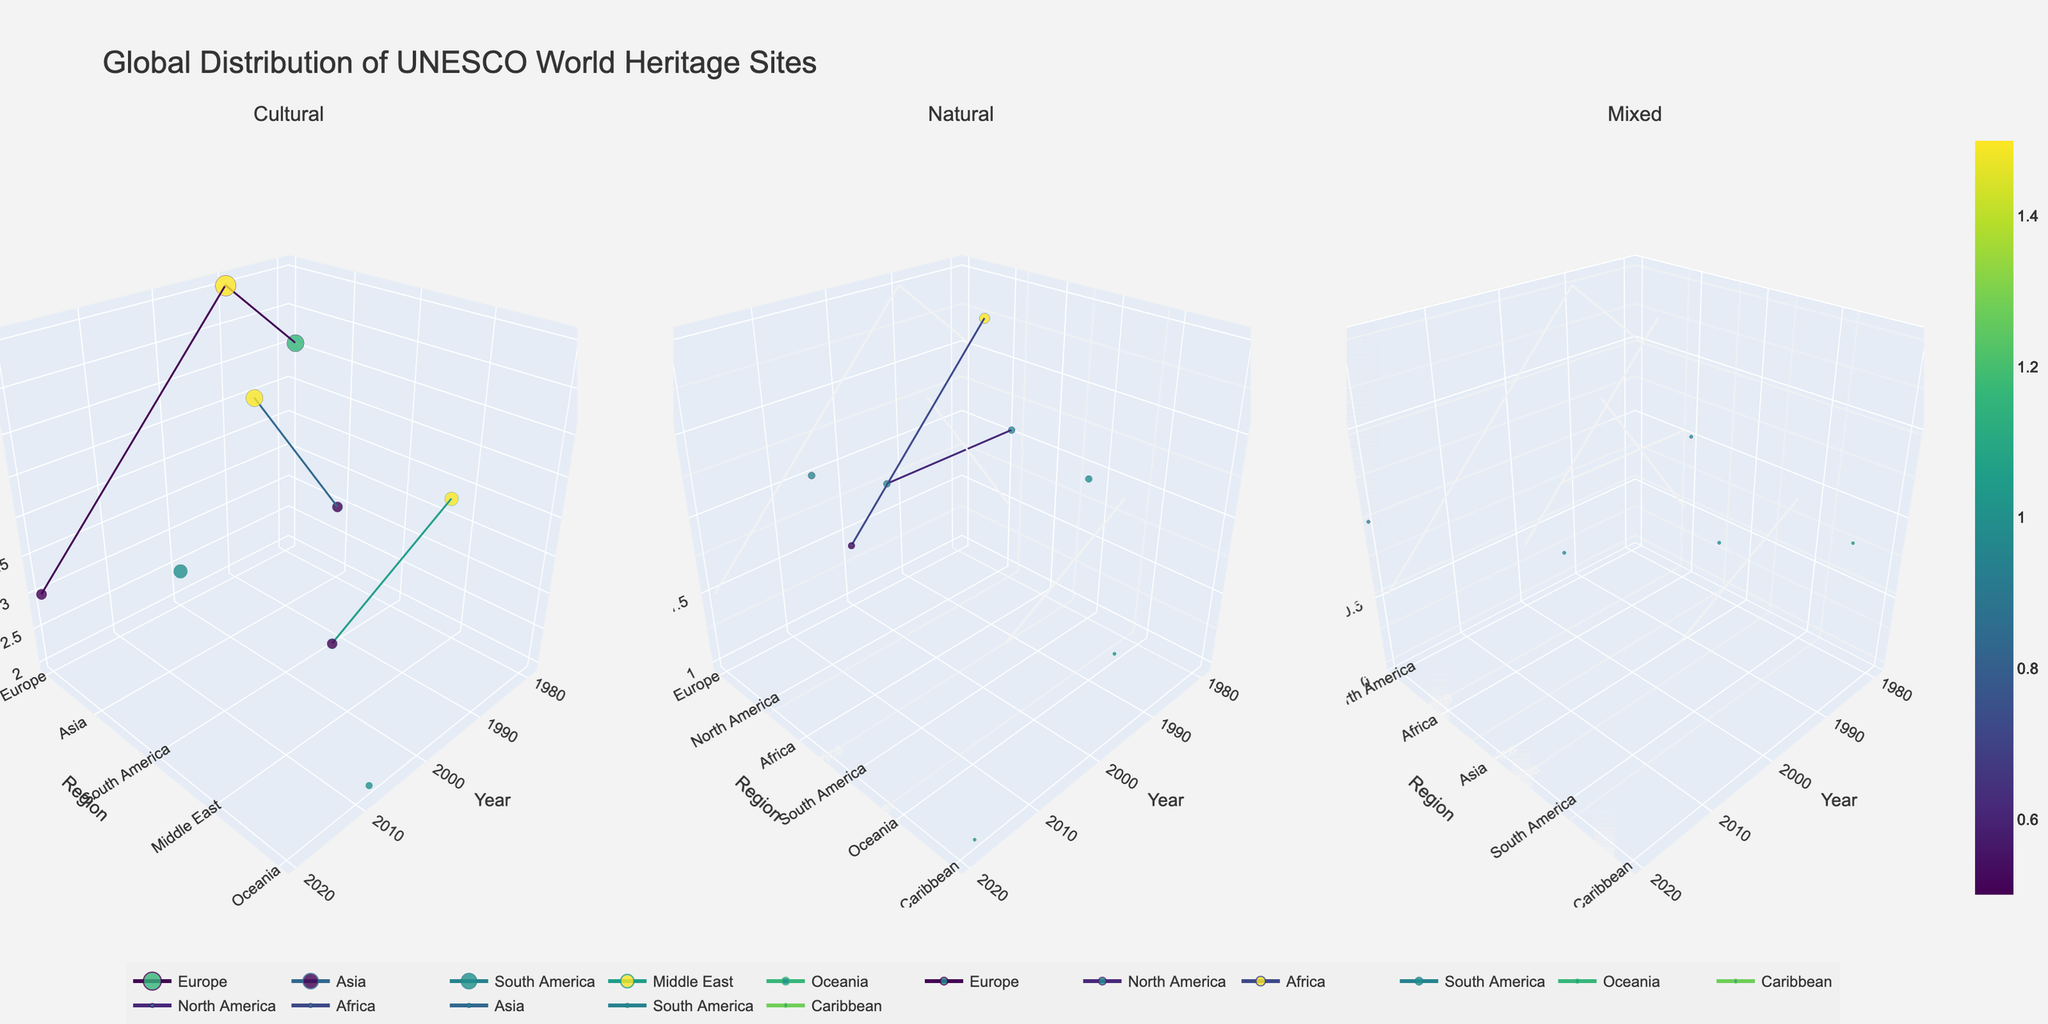When were the first UNESCO World Heritage Sites inscribed in each site type (Cultural, Natural, Mixed)? Look at the x-axis (Year) for each subplot (Cultural, Natural, Mixed) and identify the earliest year displayed for each type. The earliest year for Cultural sites is 1978, for Natural sites is 1978, and for Mixed sites is 1979.
Answer: Cultural: 1978, Natural: 1978, Mixed: 1979 Which region has the highest number of Cultural sites inscribed in a single year? In the Cultural subplot, find the region with the highest z-values across all years by comparing the height of the markers. Europe in 1990 has the highest count of 6.
Answer: Europe How does the trend of Natural sites in Africa change over the years? In the Natural subplot, observe the markers and lines representing Africa. The count starts at 3 in 1992, decreases to 2 in 2012, showing a slight decline over the years.
Answer: Declines Which year witnessed the highest number of Mixed sites being inscribed? Look at the Mixed subplot and find the tallest marker along the z-axis (Count). The year 2010 has a count of 1, similarly seen in other years, but it is consistent.
Answer: 2010 Comparing Mixed site inscriptions, which region had the latest inscription, and in what year did it occur? In the Mixed subplot, find the most recent year on the x-axis. North America in 2021 has the latest inscription.
Answer: North America, 2021 What is the regional distribution of Natural sites inscribed over the years? In the Natural subplot, observe the markers representing different regions and note their spread along the x-axis (Year). Regions include North America (1978, 2000), South America (1982), Africa (1992, 2012), Oceania (1985), Europe (2005), and Caribbean (2018).
Answer: North America: 1978, 2000; South America: 1982; Africa: 1992, 2012; Oceania: 1985; Europe: 2005; Caribbean: 2018 How many Cultural sites were inscribed in the Middle East by 2003? In the Cultural subplot, look for the markers along the y-axis labeled Middle East and note their z-values up to the year 2003. There were inscriptions in 1983 (4) and 2003 (3), totaling to 7.
Answer: 7 In what year did the Europe region see its first Natural site inscribed? In the Natural subplot, find the first marker along the y-axis labeled Europe and note its corresponding year on the x-axis. The first Natural site in Europe was inscribed in 2005.
Answer: 2005 What pattern can be observed in the inscription of Mixed sites in South America? Look at the Mixed subplot and observe the markers for South America. Only one inscription is observed in 1997, and no other years show additional inscriptions, indicating a singular event.
Answer: Singular inscription in 1997 